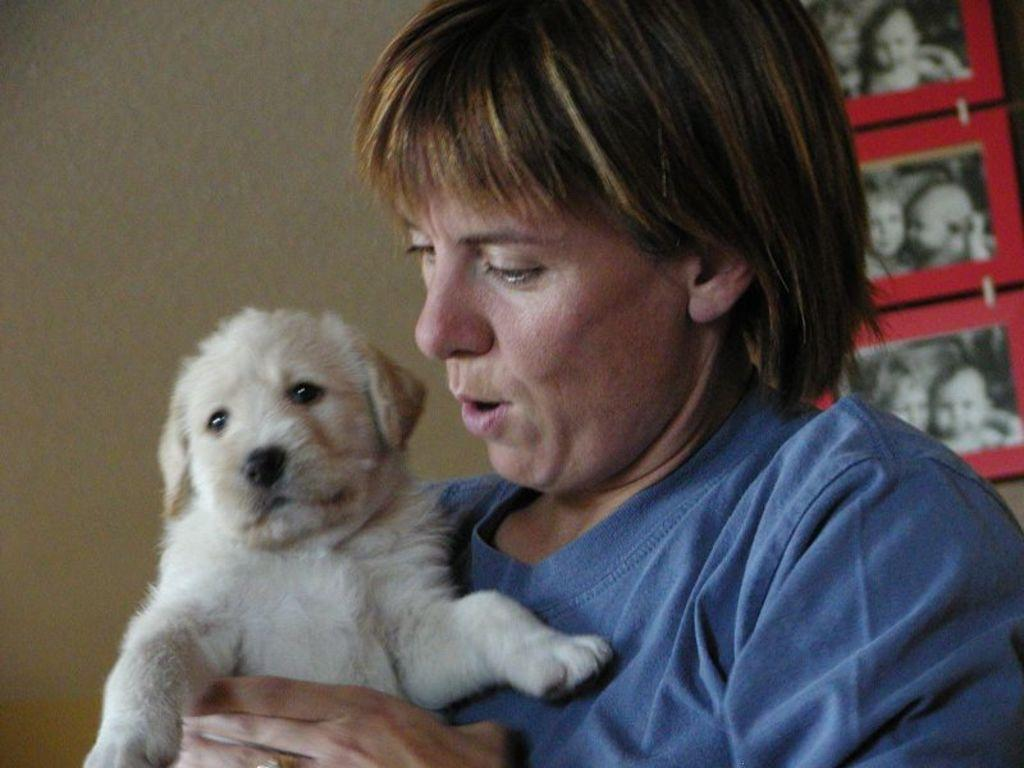Who is the main subject in the image? There is a woman in the image. What is the woman doing in the image? The woman is holding a dog. What is the woman wearing in the image? The woman is wearing a blue t-shirt. What can be seen in the background of the image? There are photos in the background of the image. Are there any giants visible in the image? No, there are no giants present in the image. What type of bushes can be seen in the image? There are no bushes visible in the image. 